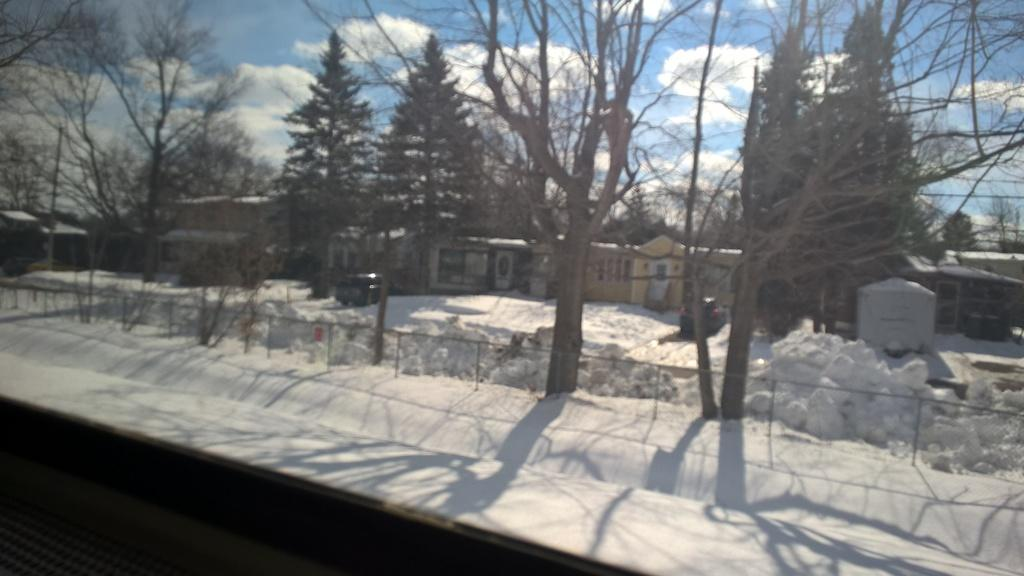What type of weather is depicted in the image? There is snow in the image, indicating a winter scene. What type of structure can be seen in the image? There is a fence in the image. What type of natural elements are present in the image? There are trees in the image. What type of man-made objects can be seen in the image? There are vehicles and houses in the image. What type of vertical structure is present in the image? There is a pole in the image. What is visible in the background of the image? The sky with clouds is visible in the background of the image. What is the answer to the riddle written on the side of the house in the image? There is no riddle written on the side of the house in the image. Can you tell me how many people are driving the vehicles in the image? The image does not show the vehicles in motion or any drivers, so it cannot be determined how many people are driving the vehicles. 